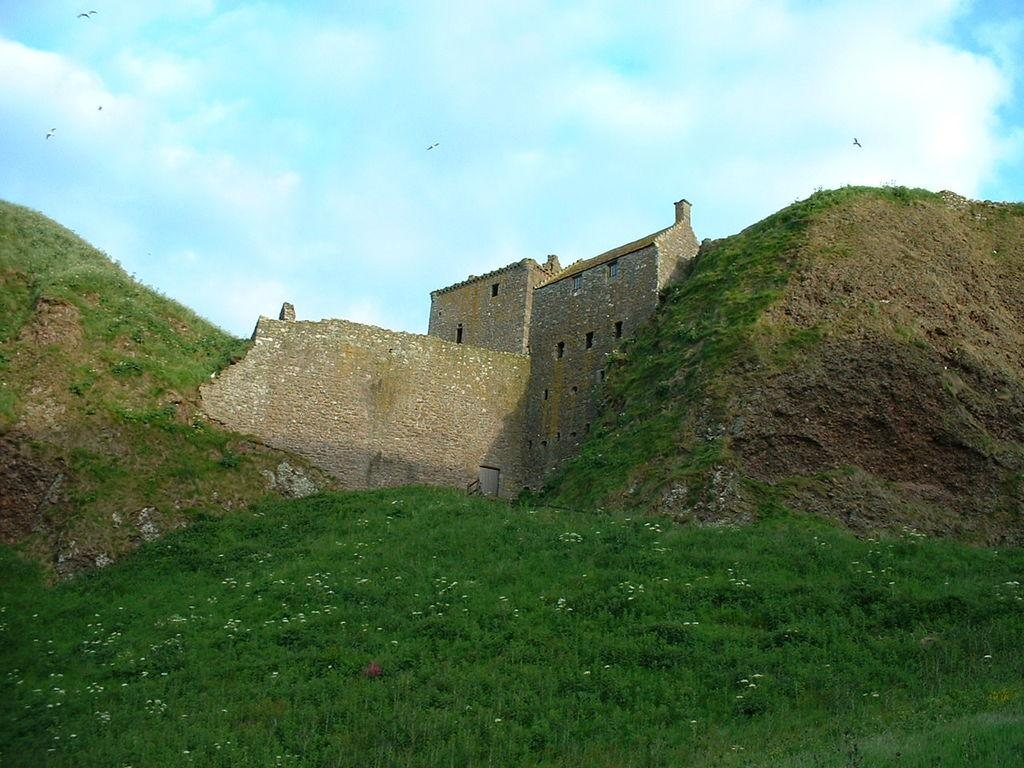What type of terrain is visible at the bottom of the image? There is grass on the ground at the bottom of the image. What natural features can be seen in the background of the image? There are mountains in the background of the image. What man-made structures are visible in the background of the image? There are buildings and a wall in the background of the image. What is visible in the sky in the background of the image? There are clouds in the sky in the background of the image. Where is the hidden jewel located in the image? There is no mention of a jewel in the image, so it cannot be located. 